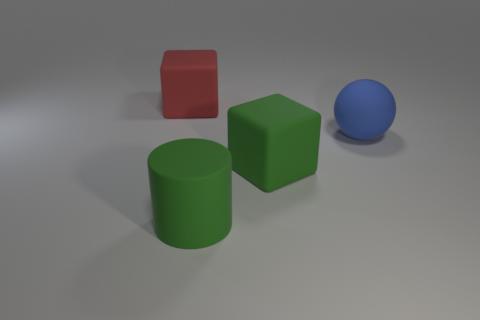Add 1 big red matte cubes. How many objects exist? 5 Subtract 1 cylinders. How many cylinders are left? 0 Subtract all balls. How many objects are left? 3 Add 4 blue matte spheres. How many blue matte spheres are left? 5 Add 3 small metal blocks. How many small metal blocks exist? 3 Subtract all green blocks. How many blocks are left? 1 Subtract 0 yellow balls. How many objects are left? 4 Subtract all cyan blocks. Subtract all cyan cylinders. How many blocks are left? 2 Subtract all big red cylinders. Subtract all large green things. How many objects are left? 2 